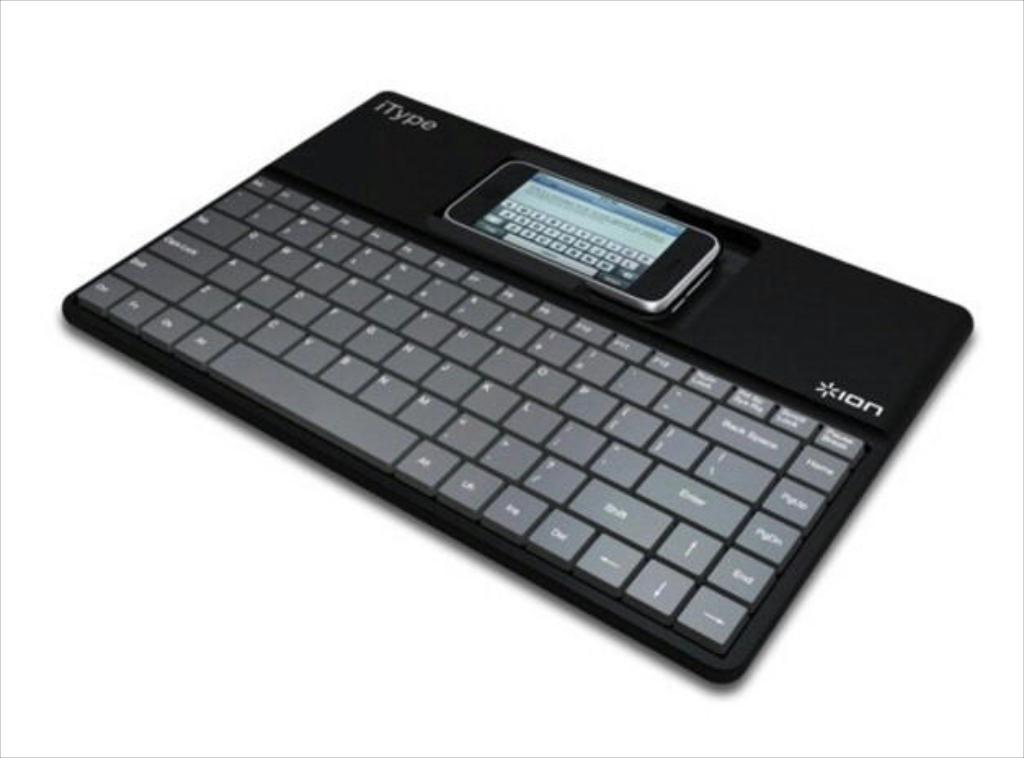<image>
Render a clear and concise summary of the photo. the itype keyboard attaches to a phone at the top 